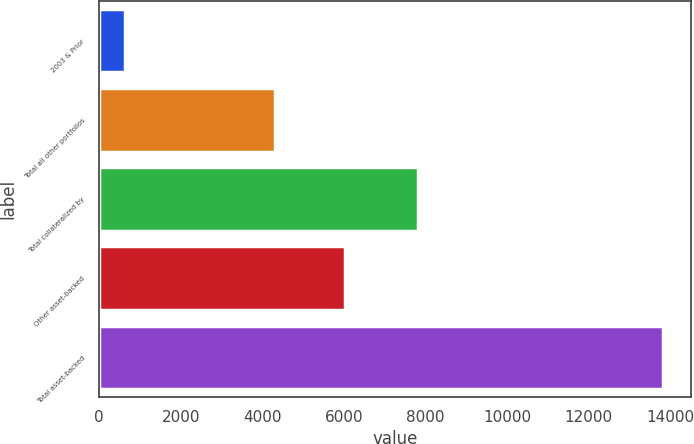<chart> <loc_0><loc_0><loc_500><loc_500><bar_chart><fcel>2003 & Prior<fcel>Total all other portfolios<fcel>Total collateralized by<fcel>Other asset-backed<fcel>Total asset-backed<nl><fcel>640<fcel>4311<fcel>7812<fcel>6021<fcel>13833<nl></chart> 